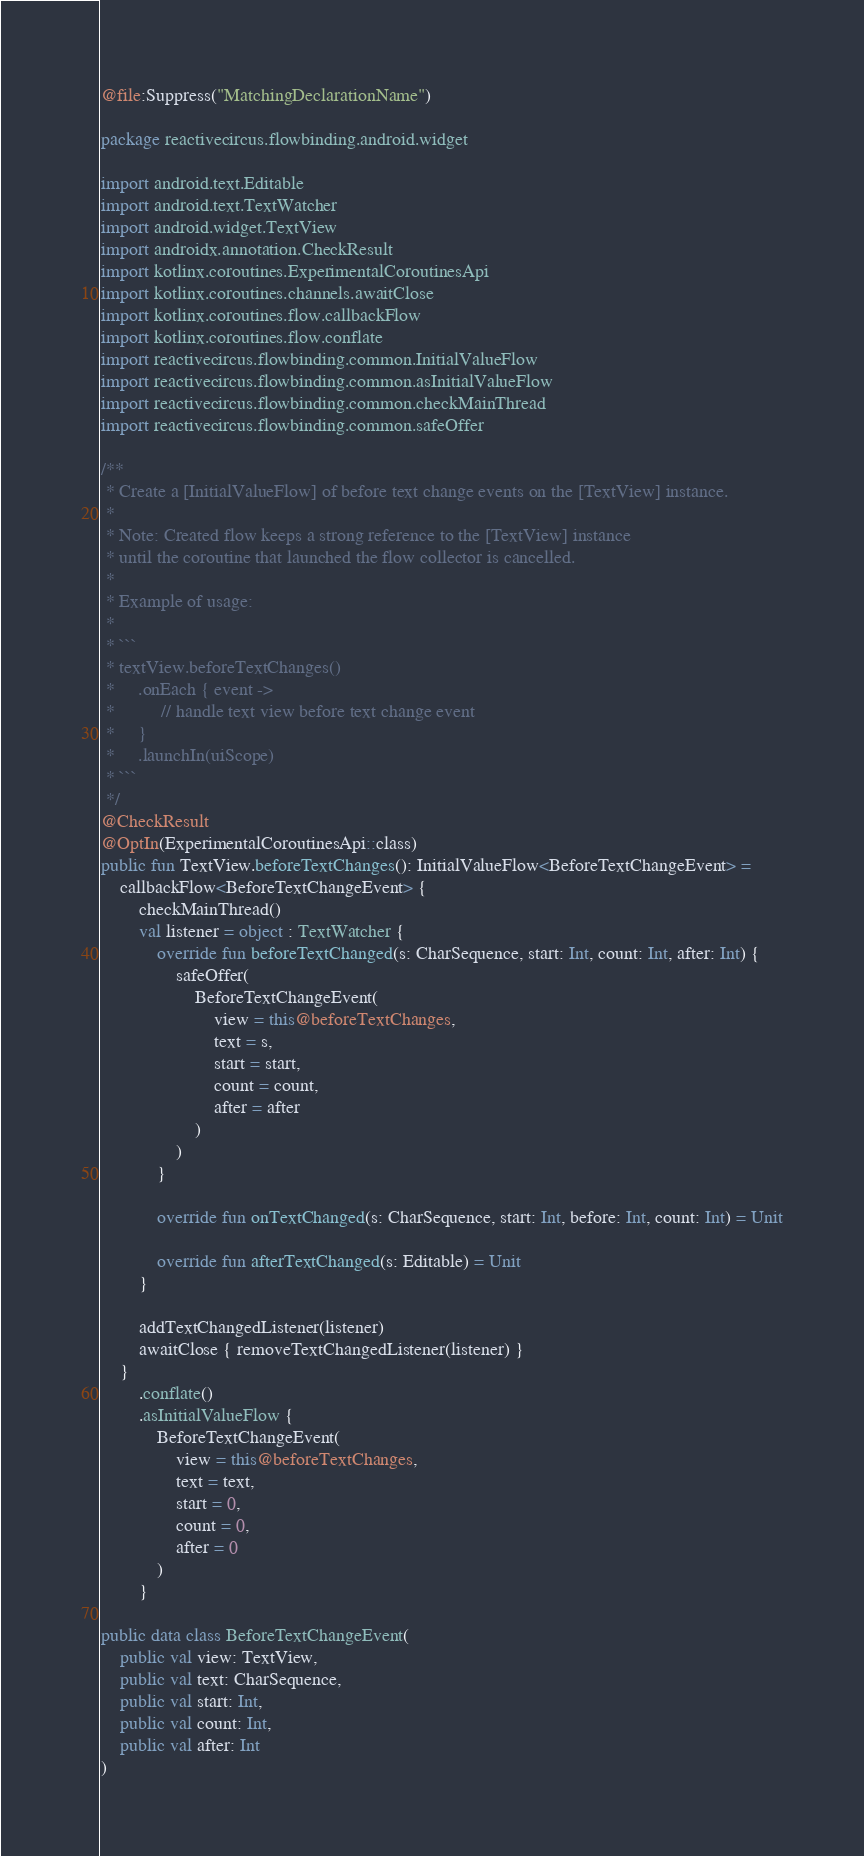<code> <loc_0><loc_0><loc_500><loc_500><_Kotlin_>@file:Suppress("MatchingDeclarationName")

package reactivecircus.flowbinding.android.widget

import android.text.Editable
import android.text.TextWatcher
import android.widget.TextView
import androidx.annotation.CheckResult
import kotlinx.coroutines.ExperimentalCoroutinesApi
import kotlinx.coroutines.channels.awaitClose
import kotlinx.coroutines.flow.callbackFlow
import kotlinx.coroutines.flow.conflate
import reactivecircus.flowbinding.common.InitialValueFlow
import reactivecircus.flowbinding.common.asInitialValueFlow
import reactivecircus.flowbinding.common.checkMainThread
import reactivecircus.flowbinding.common.safeOffer

/**
 * Create a [InitialValueFlow] of before text change events on the [TextView] instance.
 *
 * Note: Created flow keeps a strong reference to the [TextView] instance
 * until the coroutine that launched the flow collector is cancelled.
 *
 * Example of usage:
 *
 * ```
 * textView.beforeTextChanges()
 *     .onEach { event ->
 *          // handle text view before text change event
 *     }
 *     .launchIn(uiScope)
 * ```
 */
@CheckResult
@OptIn(ExperimentalCoroutinesApi::class)
public fun TextView.beforeTextChanges(): InitialValueFlow<BeforeTextChangeEvent> =
    callbackFlow<BeforeTextChangeEvent> {
        checkMainThread()
        val listener = object : TextWatcher {
            override fun beforeTextChanged(s: CharSequence, start: Int, count: Int, after: Int) {
                safeOffer(
                    BeforeTextChangeEvent(
                        view = this@beforeTextChanges,
                        text = s,
                        start = start,
                        count = count,
                        after = after
                    )
                )
            }

            override fun onTextChanged(s: CharSequence, start: Int, before: Int, count: Int) = Unit

            override fun afterTextChanged(s: Editable) = Unit
        }

        addTextChangedListener(listener)
        awaitClose { removeTextChangedListener(listener) }
    }
        .conflate()
        .asInitialValueFlow {
            BeforeTextChangeEvent(
                view = this@beforeTextChanges,
                text = text,
                start = 0,
                count = 0,
                after = 0
            )
        }

public data class BeforeTextChangeEvent(
    public val view: TextView,
    public val text: CharSequence,
    public val start: Int,
    public val count: Int,
    public val after: Int
)
</code> 